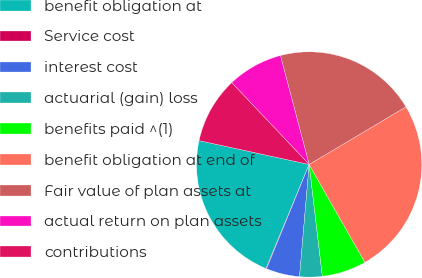Convert chart to OTSL. <chart><loc_0><loc_0><loc_500><loc_500><pie_chart><fcel>benefit obligation at<fcel>Service cost<fcel>interest cost<fcel>actuarial (gain) loss<fcel>benefits paid ^(1)<fcel>benefit obligation at end of<fcel>Fair value of plan assets at<fcel>actual return on plan assets<fcel>contributions<nl><fcel>22.14%<fcel>0.08%<fcel>4.81%<fcel>3.23%<fcel>6.38%<fcel>25.29%<fcel>20.56%<fcel>7.96%<fcel>9.54%<nl></chart> 